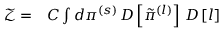Convert formula to latex. <formula><loc_0><loc_0><loc_500><loc_500>\begin{array} { r l } { \mathcal { Z } = } & C \int d \pi ^ { ( s ) } \, D \left [ \tilde { \pi } ^ { ( l ) } \right ] \, D \left [ l \right ] } \end{array}</formula> 